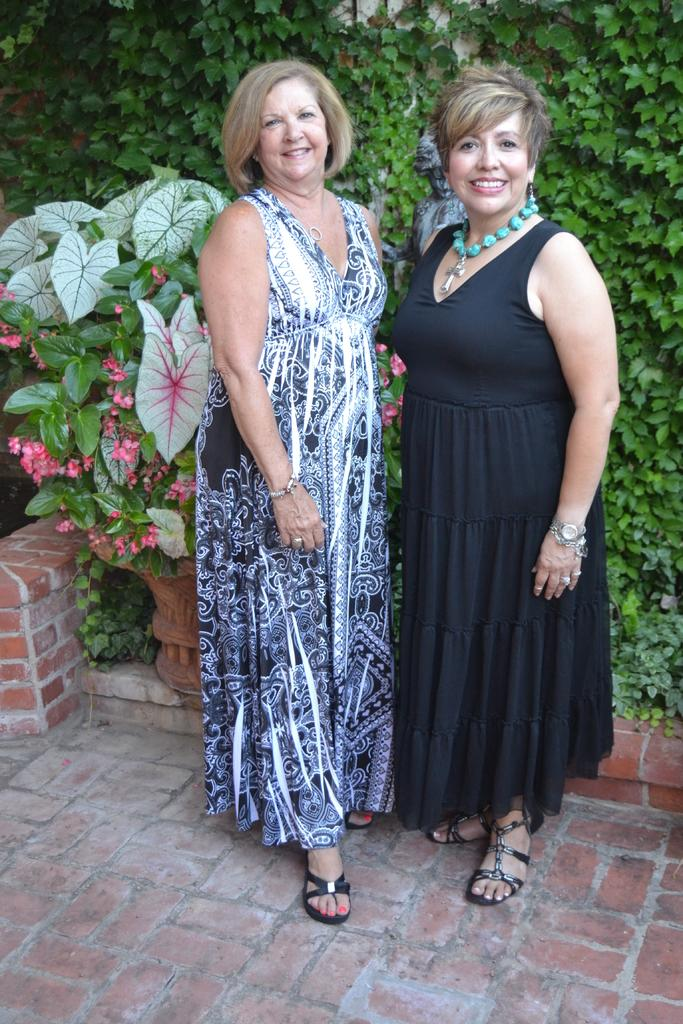How many people are in the image? There are two persons in the image. What are the persons doing in the image? The persons are standing and smiling. What can be seen in the background of the image? There are plants and flowers in the background of the image. Can you see any squirrels or worms in the image? No, there are no squirrels or worms present in the image. 